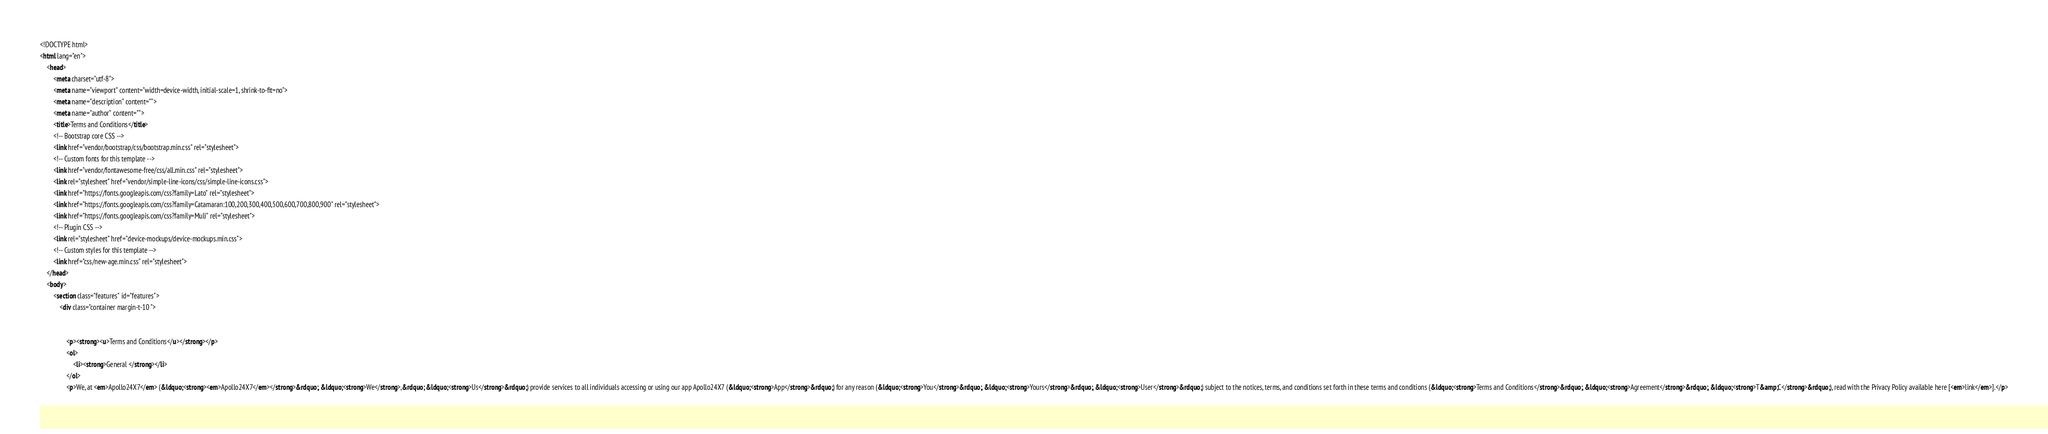<code> <loc_0><loc_0><loc_500><loc_500><_HTML_><!DOCTYPE html>
<html lang="en">
    <head>
        <meta charset="utf-8">
        <meta name="viewport" content="width=device-width, initial-scale=1, shrink-to-fit=no">
        <meta name="description" content="">
        <meta name="author" content="">
        <title>Terms and Conditions</title>
        <!-- Bootstrap core CSS -->
        <link href="vendor/bootstrap/css/bootstrap.min.css" rel="stylesheet">
        <!-- Custom fonts for this template -->
        <link href="vendor/fontawesome-free/css/all.min.css" rel="stylesheet">
        <link rel="stylesheet" href="vendor/simple-line-icons/css/simple-line-icons.css">
        <link href="https://fonts.googleapis.com/css?family=Lato" rel="stylesheet">
        <link href="https://fonts.googleapis.com/css?family=Catamaran:100,200,300,400,500,600,700,800,900" rel="stylesheet">
        <link href="https://fonts.googleapis.com/css?family=Muli" rel="stylesheet">
        <!-- Plugin CSS -->
        <link rel="stylesheet" href="device-mockups/device-mockups.min.css">
        <!-- Custom styles for this template -->
        <link href="css/new-age.min.css" rel="stylesheet">
    </head>
    <body>
        <section class="features" id="features">
            <div class="container margin-t-10 ">
                
                
                <p><strong><u>Terms and Conditions</u></strong></p>
                <ol>
                    <li><strong>General </strong></li>
                </ol>
                <p>We, at <em>Apollo24X7</em> (&ldquo;<strong><em>Apollo24X7</em></strong>&rdquo;, &ldquo;<strong>We</strong>,&rdquo; &ldquo;<strong>Us</strong>&rdquo;) provide services to all individuals accessing or using our app Apollo24X7 (&ldquo;<strong>App</strong>&rdquo;) for any reason (&ldquo;<strong>You</strong>&rdquo;, &ldquo;<strong>Yours</strong>&rdquo;, &ldquo;<strong>User</strong>&rdquo;) subject to the notices, terms, and conditions set forth in these terms and conditions (&ldquo;<strong>Terms and Conditions</strong>&rdquo;, &ldquo;<strong>Agreement</strong>&rdquo;, &ldquo;<strong>T&amp;C</strong>&rdquo;), read with the Privacy Policy available here [<em>link</em>].</p></code> 